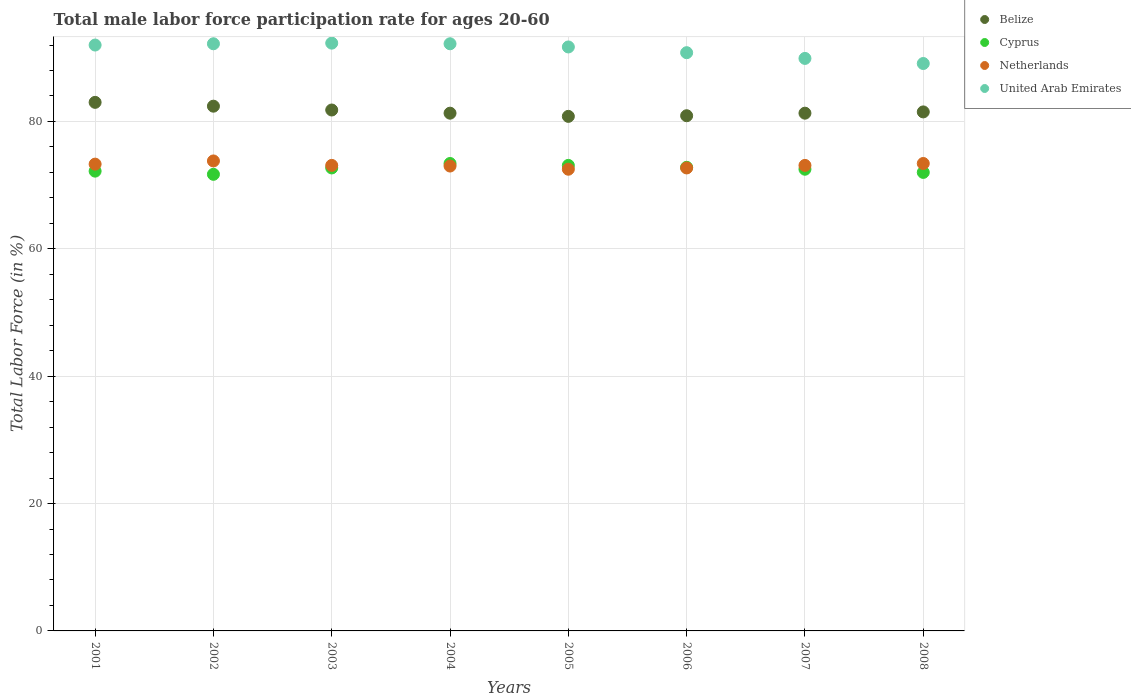How many different coloured dotlines are there?
Your response must be concise. 4. Across all years, what is the maximum male labor force participation rate in United Arab Emirates?
Your answer should be very brief. 92.3. Across all years, what is the minimum male labor force participation rate in Cyprus?
Offer a very short reply. 71.7. In which year was the male labor force participation rate in United Arab Emirates maximum?
Your response must be concise. 2003. In which year was the male labor force participation rate in Netherlands minimum?
Offer a terse response. 2005. What is the total male labor force participation rate in Netherlands in the graph?
Provide a short and direct response. 584.9. What is the difference between the male labor force participation rate in Belize in 2003 and that in 2005?
Keep it short and to the point. 1. What is the average male labor force participation rate in United Arab Emirates per year?
Provide a short and direct response. 91.27. In the year 2007, what is the difference between the male labor force participation rate in Netherlands and male labor force participation rate in Cyprus?
Ensure brevity in your answer.  0.6. What is the ratio of the male labor force participation rate in United Arab Emirates in 2005 to that in 2006?
Ensure brevity in your answer.  1.01. Is the male labor force participation rate in Belize in 2005 less than that in 2008?
Keep it short and to the point. Yes. Is the difference between the male labor force participation rate in Netherlands in 2006 and 2008 greater than the difference between the male labor force participation rate in Cyprus in 2006 and 2008?
Provide a succinct answer. No. What is the difference between the highest and the second highest male labor force participation rate in Netherlands?
Your answer should be very brief. 0.4. What is the difference between the highest and the lowest male labor force participation rate in United Arab Emirates?
Offer a very short reply. 3.2. In how many years, is the male labor force participation rate in Cyprus greater than the average male labor force participation rate in Cyprus taken over all years?
Keep it short and to the point. 4. Is it the case that in every year, the sum of the male labor force participation rate in Belize and male labor force participation rate in United Arab Emirates  is greater than the sum of male labor force participation rate in Cyprus and male labor force participation rate in Netherlands?
Make the answer very short. Yes. Does the male labor force participation rate in Netherlands monotonically increase over the years?
Offer a very short reply. No. Are the values on the major ticks of Y-axis written in scientific E-notation?
Offer a terse response. No. Does the graph contain any zero values?
Your answer should be very brief. No. Does the graph contain grids?
Your response must be concise. Yes. How many legend labels are there?
Your answer should be very brief. 4. What is the title of the graph?
Ensure brevity in your answer.  Total male labor force participation rate for ages 20-60. What is the label or title of the X-axis?
Your answer should be very brief. Years. What is the Total Labor Force (in %) in Belize in 2001?
Your answer should be very brief. 83. What is the Total Labor Force (in %) of Cyprus in 2001?
Give a very brief answer. 72.2. What is the Total Labor Force (in %) in Netherlands in 2001?
Offer a very short reply. 73.3. What is the Total Labor Force (in %) in United Arab Emirates in 2001?
Your answer should be compact. 92. What is the Total Labor Force (in %) in Belize in 2002?
Give a very brief answer. 82.4. What is the Total Labor Force (in %) of Cyprus in 2002?
Offer a terse response. 71.7. What is the Total Labor Force (in %) of Netherlands in 2002?
Your answer should be very brief. 73.8. What is the Total Labor Force (in %) of United Arab Emirates in 2002?
Offer a terse response. 92.2. What is the Total Labor Force (in %) of Belize in 2003?
Make the answer very short. 81.8. What is the Total Labor Force (in %) of Cyprus in 2003?
Offer a terse response. 72.7. What is the Total Labor Force (in %) in Netherlands in 2003?
Your response must be concise. 73.1. What is the Total Labor Force (in %) in United Arab Emirates in 2003?
Your answer should be compact. 92.3. What is the Total Labor Force (in %) in Belize in 2004?
Provide a succinct answer. 81.3. What is the Total Labor Force (in %) in Cyprus in 2004?
Your answer should be very brief. 73.4. What is the Total Labor Force (in %) in Netherlands in 2004?
Make the answer very short. 73. What is the Total Labor Force (in %) of United Arab Emirates in 2004?
Keep it short and to the point. 92.2. What is the Total Labor Force (in %) of Belize in 2005?
Your answer should be very brief. 80.8. What is the Total Labor Force (in %) in Cyprus in 2005?
Your response must be concise. 73.1. What is the Total Labor Force (in %) of Netherlands in 2005?
Offer a very short reply. 72.5. What is the Total Labor Force (in %) in United Arab Emirates in 2005?
Offer a terse response. 91.7. What is the Total Labor Force (in %) in Belize in 2006?
Offer a very short reply. 80.9. What is the Total Labor Force (in %) in Cyprus in 2006?
Your answer should be compact. 72.8. What is the Total Labor Force (in %) of Netherlands in 2006?
Your answer should be compact. 72.7. What is the Total Labor Force (in %) in United Arab Emirates in 2006?
Give a very brief answer. 90.8. What is the Total Labor Force (in %) in Belize in 2007?
Make the answer very short. 81.3. What is the Total Labor Force (in %) in Cyprus in 2007?
Ensure brevity in your answer.  72.5. What is the Total Labor Force (in %) of Netherlands in 2007?
Ensure brevity in your answer.  73.1. What is the Total Labor Force (in %) of United Arab Emirates in 2007?
Ensure brevity in your answer.  89.9. What is the Total Labor Force (in %) in Belize in 2008?
Your answer should be very brief. 81.5. What is the Total Labor Force (in %) in Netherlands in 2008?
Keep it short and to the point. 73.4. What is the Total Labor Force (in %) of United Arab Emirates in 2008?
Provide a short and direct response. 89.1. Across all years, what is the maximum Total Labor Force (in %) in Belize?
Your answer should be compact. 83. Across all years, what is the maximum Total Labor Force (in %) of Cyprus?
Keep it short and to the point. 73.4. Across all years, what is the maximum Total Labor Force (in %) of Netherlands?
Make the answer very short. 73.8. Across all years, what is the maximum Total Labor Force (in %) of United Arab Emirates?
Offer a terse response. 92.3. Across all years, what is the minimum Total Labor Force (in %) in Belize?
Your answer should be very brief. 80.8. Across all years, what is the minimum Total Labor Force (in %) of Cyprus?
Make the answer very short. 71.7. Across all years, what is the minimum Total Labor Force (in %) of Netherlands?
Your answer should be very brief. 72.5. Across all years, what is the minimum Total Labor Force (in %) of United Arab Emirates?
Your answer should be compact. 89.1. What is the total Total Labor Force (in %) in Belize in the graph?
Your response must be concise. 653. What is the total Total Labor Force (in %) of Cyprus in the graph?
Provide a succinct answer. 580.4. What is the total Total Labor Force (in %) of Netherlands in the graph?
Keep it short and to the point. 584.9. What is the total Total Labor Force (in %) of United Arab Emirates in the graph?
Keep it short and to the point. 730.2. What is the difference between the Total Labor Force (in %) in Belize in 2001 and that in 2002?
Ensure brevity in your answer.  0.6. What is the difference between the Total Labor Force (in %) in United Arab Emirates in 2001 and that in 2002?
Your answer should be very brief. -0.2. What is the difference between the Total Labor Force (in %) of Belize in 2001 and that in 2003?
Ensure brevity in your answer.  1.2. What is the difference between the Total Labor Force (in %) of Cyprus in 2001 and that in 2003?
Your answer should be very brief. -0.5. What is the difference between the Total Labor Force (in %) in Netherlands in 2001 and that in 2003?
Your answer should be very brief. 0.2. What is the difference between the Total Labor Force (in %) of Belize in 2001 and that in 2004?
Give a very brief answer. 1.7. What is the difference between the Total Labor Force (in %) in Netherlands in 2001 and that in 2004?
Ensure brevity in your answer.  0.3. What is the difference between the Total Labor Force (in %) in United Arab Emirates in 2001 and that in 2004?
Provide a succinct answer. -0.2. What is the difference between the Total Labor Force (in %) in Belize in 2001 and that in 2005?
Your answer should be compact. 2.2. What is the difference between the Total Labor Force (in %) of Netherlands in 2001 and that in 2005?
Provide a short and direct response. 0.8. What is the difference between the Total Labor Force (in %) of Belize in 2001 and that in 2006?
Provide a short and direct response. 2.1. What is the difference between the Total Labor Force (in %) in Cyprus in 2001 and that in 2006?
Your answer should be very brief. -0.6. What is the difference between the Total Labor Force (in %) of Netherlands in 2001 and that in 2006?
Give a very brief answer. 0.6. What is the difference between the Total Labor Force (in %) in United Arab Emirates in 2001 and that in 2006?
Provide a succinct answer. 1.2. What is the difference between the Total Labor Force (in %) in Belize in 2001 and that in 2007?
Provide a short and direct response. 1.7. What is the difference between the Total Labor Force (in %) of Cyprus in 2001 and that in 2007?
Your response must be concise. -0.3. What is the difference between the Total Labor Force (in %) of Netherlands in 2001 and that in 2007?
Offer a very short reply. 0.2. What is the difference between the Total Labor Force (in %) of United Arab Emirates in 2001 and that in 2007?
Provide a succinct answer. 2.1. What is the difference between the Total Labor Force (in %) of Belize in 2001 and that in 2008?
Give a very brief answer. 1.5. What is the difference between the Total Labor Force (in %) in Cyprus in 2001 and that in 2008?
Make the answer very short. 0.2. What is the difference between the Total Labor Force (in %) of United Arab Emirates in 2001 and that in 2008?
Your answer should be very brief. 2.9. What is the difference between the Total Labor Force (in %) in Cyprus in 2002 and that in 2003?
Give a very brief answer. -1. What is the difference between the Total Labor Force (in %) of Netherlands in 2002 and that in 2003?
Ensure brevity in your answer.  0.7. What is the difference between the Total Labor Force (in %) in United Arab Emirates in 2002 and that in 2003?
Your answer should be very brief. -0.1. What is the difference between the Total Labor Force (in %) in Belize in 2002 and that in 2004?
Your answer should be compact. 1.1. What is the difference between the Total Labor Force (in %) of Cyprus in 2002 and that in 2004?
Keep it short and to the point. -1.7. What is the difference between the Total Labor Force (in %) of Belize in 2002 and that in 2005?
Make the answer very short. 1.6. What is the difference between the Total Labor Force (in %) of Netherlands in 2002 and that in 2005?
Your answer should be very brief. 1.3. What is the difference between the Total Labor Force (in %) of United Arab Emirates in 2002 and that in 2005?
Offer a terse response. 0.5. What is the difference between the Total Labor Force (in %) of Cyprus in 2002 and that in 2006?
Your response must be concise. -1.1. What is the difference between the Total Labor Force (in %) in Belize in 2002 and that in 2007?
Keep it short and to the point. 1.1. What is the difference between the Total Labor Force (in %) in Belize in 2002 and that in 2008?
Keep it short and to the point. 0.9. What is the difference between the Total Labor Force (in %) of Netherlands in 2002 and that in 2008?
Offer a terse response. 0.4. What is the difference between the Total Labor Force (in %) in United Arab Emirates in 2002 and that in 2008?
Offer a terse response. 3.1. What is the difference between the Total Labor Force (in %) of Belize in 2003 and that in 2004?
Offer a terse response. 0.5. What is the difference between the Total Labor Force (in %) of Cyprus in 2003 and that in 2004?
Your answer should be very brief. -0.7. What is the difference between the Total Labor Force (in %) in Netherlands in 2003 and that in 2004?
Provide a succinct answer. 0.1. What is the difference between the Total Labor Force (in %) of Cyprus in 2003 and that in 2006?
Your answer should be compact. -0.1. What is the difference between the Total Labor Force (in %) in Netherlands in 2003 and that in 2006?
Offer a very short reply. 0.4. What is the difference between the Total Labor Force (in %) of Cyprus in 2003 and that in 2007?
Offer a terse response. 0.2. What is the difference between the Total Labor Force (in %) in Netherlands in 2003 and that in 2007?
Make the answer very short. 0. What is the difference between the Total Labor Force (in %) of Belize in 2003 and that in 2008?
Ensure brevity in your answer.  0.3. What is the difference between the Total Labor Force (in %) of Belize in 2004 and that in 2005?
Ensure brevity in your answer.  0.5. What is the difference between the Total Labor Force (in %) in Netherlands in 2004 and that in 2005?
Offer a terse response. 0.5. What is the difference between the Total Labor Force (in %) of United Arab Emirates in 2004 and that in 2005?
Your answer should be very brief. 0.5. What is the difference between the Total Labor Force (in %) in Belize in 2004 and that in 2006?
Provide a succinct answer. 0.4. What is the difference between the Total Labor Force (in %) in United Arab Emirates in 2004 and that in 2006?
Your answer should be compact. 1.4. What is the difference between the Total Labor Force (in %) of Cyprus in 2004 and that in 2007?
Give a very brief answer. 0.9. What is the difference between the Total Labor Force (in %) in United Arab Emirates in 2004 and that in 2007?
Offer a terse response. 2.3. What is the difference between the Total Labor Force (in %) of Netherlands in 2004 and that in 2008?
Your response must be concise. -0.4. What is the difference between the Total Labor Force (in %) in Cyprus in 2005 and that in 2007?
Offer a very short reply. 0.6. What is the difference between the Total Labor Force (in %) in Netherlands in 2005 and that in 2007?
Provide a short and direct response. -0.6. What is the difference between the Total Labor Force (in %) in Belize in 2005 and that in 2008?
Your answer should be very brief. -0.7. What is the difference between the Total Labor Force (in %) in Cyprus in 2005 and that in 2008?
Offer a very short reply. 1.1. What is the difference between the Total Labor Force (in %) in Netherlands in 2005 and that in 2008?
Your answer should be very brief. -0.9. What is the difference between the Total Labor Force (in %) in United Arab Emirates in 2005 and that in 2008?
Provide a short and direct response. 2.6. What is the difference between the Total Labor Force (in %) in Netherlands in 2006 and that in 2007?
Provide a succinct answer. -0.4. What is the difference between the Total Labor Force (in %) of Cyprus in 2006 and that in 2008?
Provide a short and direct response. 0.8. What is the difference between the Total Labor Force (in %) in Netherlands in 2006 and that in 2008?
Your answer should be compact. -0.7. What is the difference between the Total Labor Force (in %) in United Arab Emirates in 2007 and that in 2008?
Give a very brief answer. 0.8. What is the difference between the Total Labor Force (in %) in Belize in 2001 and the Total Labor Force (in %) in Netherlands in 2002?
Offer a very short reply. 9.2. What is the difference between the Total Labor Force (in %) of Belize in 2001 and the Total Labor Force (in %) of United Arab Emirates in 2002?
Your response must be concise. -9.2. What is the difference between the Total Labor Force (in %) in Cyprus in 2001 and the Total Labor Force (in %) in United Arab Emirates in 2002?
Offer a very short reply. -20. What is the difference between the Total Labor Force (in %) of Netherlands in 2001 and the Total Labor Force (in %) of United Arab Emirates in 2002?
Offer a terse response. -18.9. What is the difference between the Total Labor Force (in %) in Belize in 2001 and the Total Labor Force (in %) in Cyprus in 2003?
Your answer should be very brief. 10.3. What is the difference between the Total Labor Force (in %) of Belize in 2001 and the Total Labor Force (in %) of Netherlands in 2003?
Keep it short and to the point. 9.9. What is the difference between the Total Labor Force (in %) in Belize in 2001 and the Total Labor Force (in %) in United Arab Emirates in 2003?
Make the answer very short. -9.3. What is the difference between the Total Labor Force (in %) of Cyprus in 2001 and the Total Labor Force (in %) of United Arab Emirates in 2003?
Offer a very short reply. -20.1. What is the difference between the Total Labor Force (in %) in Belize in 2001 and the Total Labor Force (in %) in Netherlands in 2004?
Ensure brevity in your answer.  10. What is the difference between the Total Labor Force (in %) of Cyprus in 2001 and the Total Labor Force (in %) of United Arab Emirates in 2004?
Offer a terse response. -20. What is the difference between the Total Labor Force (in %) of Netherlands in 2001 and the Total Labor Force (in %) of United Arab Emirates in 2004?
Your answer should be very brief. -18.9. What is the difference between the Total Labor Force (in %) in Belize in 2001 and the Total Labor Force (in %) in Cyprus in 2005?
Make the answer very short. 9.9. What is the difference between the Total Labor Force (in %) in Belize in 2001 and the Total Labor Force (in %) in Netherlands in 2005?
Give a very brief answer. 10.5. What is the difference between the Total Labor Force (in %) in Cyprus in 2001 and the Total Labor Force (in %) in United Arab Emirates in 2005?
Offer a terse response. -19.5. What is the difference between the Total Labor Force (in %) in Netherlands in 2001 and the Total Labor Force (in %) in United Arab Emirates in 2005?
Give a very brief answer. -18.4. What is the difference between the Total Labor Force (in %) in Cyprus in 2001 and the Total Labor Force (in %) in Netherlands in 2006?
Offer a terse response. -0.5. What is the difference between the Total Labor Force (in %) in Cyprus in 2001 and the Total Labor Force (in %) in United Arab Emirates in 2006?
Your answer should be compact. -18.6. What is the difference between the Total Labor Force (in %) in Netherlands in 2001 and the Total Labor Force (in %) in United Arab Emirates in 2006?
Your response must be concise. -17.5. What is the difference between the Total Labor Force (in %) in Belize in 2001 and the Total Labor Force (in %) in United Arab Emirates in 2007?
Your response must be concise. -6.9. What is the difference between the Total Labor Force (in %) in Cyprus in 2001 and the Total Labor Force (in %) in United Arab Emirates in 2007?
Your answer should be compact. -17.7. What is the difference between the Total Labor Force (in %) in Netherlands in 2001 and the Total Labor Force (in %) in United Arab Emirates in 2007?
Give a very brief answer. -16.6. What is the difference between the Total Labor Force (in %) of Belize in 2001 and the Total Labor Force (in %) of Netherlands in 2008?
Provide a short and direct response. 9.6. What is the difference between the Total Labor Force (in %) of Belize in 2001 and the Total Labor Force (in %) of United Arab Emirates in 2008?
Ensure brevity in your answer.  -6.1. What is the difference between the Total Labor Force (in %) in Cyprus in 2001 and the Total Labor Force (in %) in Netherlands in 2008?
Your answer should be compact. -1.2. What is the difference between the Total Labor Force (in %) of Cyprus in 2001 and the Total Labor Force (in %) of United Arab Emirates in 2008?
Give a very brief answer. -16.9. What is the difference between the Total Labor Force (in %) of Netherlands in 2001 and the Total Labor Force (in %) of United Arab Emirates in 2008?
Provide a succinct answer. -15.8. What is the difference between the Total Labor Force (in %) in Belize in 2002 and the Total Labor Force (in %) in Netherlands in 2003?
Your response must be concise. 9.3. What is the difference between the Total Labor Force (in %) in Cyprus in 2002 and the Total Labor Force (in %) in United Arab Emirates in 2003?
Ensure brevity in your answer.  -20.6. What is the difference between the Total Labor Force (in %) in Netherlands in 2002 and the Total Labor Force (in %) in United Arab Emirates in 2003?
Keep it short and to the point. -18.5. What is the difference between the Total Labor Force (in %) of Cyprus in 2002 and the Total Labor Force (in %) of United Arab Emirates in 2004?
Offer a terse response. -20.5. What is the difference between the Total Labor Force (in %) in Netherlands in 2002 and the Total Labor Force (in %) in United Arab Emirates in 2004?
Offer a terse response. -18.4. What is the difference between the Total Labor Force (in %) of Belize in 2002 and the Total Labor Force (in %) of Cyprus in 2005?
Ensure brevity in your answer.  9.3. What is the difference between the Total Labor Force (in %) of Belize in 2002 and the Total Labor Force (in %) of Netherlands in 2005?
Offer a very short reply. 9.9. What is the difference between the Total Labor Force (in %) of Belize in 2002 and the Total Labor Force (in %) of United Arab Emirates in 2005?
Keep it short and to the point. -9.3. What is the difference between the Total Labor Force (in %) of Cyprus in 2002 and the Total Labor Force (in %) of Netherlands in 2005?
Your answer should be very brief. -0.8. What is the difference between the Total Labor Force (in %) in Netherlands in 2002 and the Total Labor Force (in %) in United Arab Emirates in 2005?
Offer a terse response. -17.9. What is the difference between the Total Labor Force (in %) in Belize in 2002 and the Total Labor Force (in %) in Netherlands in 2006?
Offer a terse response. 9.7. What is the difference between the Total Labor Force (in %) in Belize in 2002 and the Total Labor Force (in %) in United Arab Emirates in 2006?
Your answer should be very brief. -8.4. What is the difference between the Total Labor Force (in %) in Cyprus in 2002 and the Total Labor Force (in %) in Netherlands in 2006?
Your response must be concise. -1. What is the difference between the Total Labor Force (in %) in Cyprus in 2002 and the Total Labor Force (in %) in United Arab Emirates in 2006?
Make the answer very short. -19.1. What is the difference between the Total Labor Force (in %) in Cyprus in 2002 and the Total Labor Force (in %) in United Arab Emirates in 2007?
Your answer should be very brief. -18.2. What is the difference between the Total Labor Force (in %) of Netherlands in 2002 and the Total Labor Force (in %) of United Arab Emirates in 2007?
Give a very brief answer. -16.1. What is the difference between the Total Labor Force (in %) of Belize in 2002 and the Total Labor Force (in %) of Cyprus in 2008?
Ensure brevity in your answer.  10.4. What is the difference between the Total Labor Force (in %) in Belize in 2002 and the Total Labor Force (in %) in Netherlands in 2008?
Your response must be concise. 9. What is the difference between the Total Labor Force (in %) in Belize in 2002 and the Total Labor Force (in %) in United Arab Emirates in 2008?
Keep it short and to the point. -6.7. What is the difference between the Total Labor Force (in %) of Cyprus in 2002 and the Total Labor Force (in %) of United Arab Emirates in 2008?
Your answer should be compact. -17.4. What is the difference between the Total Labor Force (in %) in Netherlands in 2002 and the Total Labor Force (in %) in United Arab Emirates in 2008?
Your answer should be very brief. -15.3. What is the difference between the Total Labor Force (in %) of Belize in 2003 and the Total Labor Force (in %) of Cyprus in 2004?
Offer a very short reply. 8.4. What is the difference between the Total Labor Force (in %) of Cyprus in 2003 and the Total Labor Force (in %) of Netherlands in 2004?
Your answer should be compact. -0.3. What is the difference between the Total Labor Force (in %) of Cyprus in 2003 and the Total Labor Force (in %) of United Arab Emirates in 2004?
Give a very brief answer. -19.5. What is the difference between the Total Labor Force (in %) in Netherlands in 2003 and the Total Labor Force (in %) in United Arab Emirates in 2004?
Your response must be concise. -19.1. What is the difference between the Total Labor Force (in %) of Belize in 2003 and the Total Labor Force (in %) of United Arab Emirates in 2005?
Ensure brevity in your answer.  -9.9. What is the difference between the Total Labor Force (in %) in Netherlands in 2003 and the Total Labor Force (in %) in United Arab Emirates in 2005?
Offer a very short reply. -18.6. What is the difference between the Total Labor Force (in %) of Belize in 2003 and the Total Labor Force (in %) of Cyprus in 2006?
Your answer should be very brief. 9. What is the difference between the Total Labor Force (in %) of Cyprus in 2003 and the Total Labor Force (in %) of Netherlands in 2006?
Make the answer very short. 0. What is the difference between the Total Labor Force (in %) in Cyprus in 2003 and the Total Labor Force (in %) in United Arab Emirates in 2006?
Your answer should be very brief. -18.1. What is the difference between the Total Labor Force (in %) of Netherlands in 2003 and the Total Labor Force (in %) of United Arab Emirates in 2006?
Your response must be concise. -17.7. What is the difference between the Total Labor Force (in %) of Belize in 2003 and the Total Labor Force (in %) of Netherlands in 2007?
Keep it short and to the point. 8.7. What is the difference between the Total Labor Force (in %) in Belize in 2003 and the Total Labor Force (in %) in United Arab Emirates in 2007?
Your response must be concise. -8.1. What is the difference between the Total Labor Force (in %) of Cyprus in 2003 and the Total Labor Force (in %) of United Arab Emirates in 2007?
Keep it short and to the point. -17.2. What is the difference between the Total Labor Force (in %) of Netherlands in 2003 and the Total Labor Force (in %) of United Arab Emirates in 2007?
Offer a terse response. -16.8. What is the difference between the Total Labor Force (in %) in Belize in 2003 and the Total Labor Force (in %) in Cyprus in 2008?
Make the answer very short. 9.8. What is the difference between the Total Labor Force (in %) of Belize in 2003 and the Total Labor Force (in %) of Netherlands in 2008?
Ensure brevity in your answer.  8.4. What is the difference between the Total Labor Force (in %) of Cyprus in 2003 and the Total Labor Force (in %) of Netherlands in 2008?
Your response must be concise. -0.7. What is the difference between the Total Labor Force (in %) in Cyprus in 2003 and the Total Labor Force (in %) in United Arab Emirates in 2008?
Provide a short and direct response. -16.4. What is the difference between the Total Labor Force (in %) of Netherlands in 2003 and the Total Labor Force (in %) of United Arab Emirates in 2008?
Give a very brief answer. -16. What is the difference between the Total Labor Force (in %) in Belize in 2004 and the Total Labor Force (in %) in United Arab Emirates in 2005?
Offer a very short reply. -10.4. What is the difference between the Total Labor Force (in %) in Cyprus in 2004 and the Total Labor Force (in %) in Netherlands in 2005?
Keep it short and to the point. 0.9. What is the difference between the Total Labor Force (in %) of Cyprus in 2004 and the Total Labor Force (in %) of United Arab Emirates in 2005?
Offer a very short reply. -18.3. What is the difference between the Total Labor Force (in %) of Netherlands in 2004 and the Total Labor Force (in %) of United Arab Emirates in 2005?
Keep it short and to the point. -18.7. What is the difference between the Total Labor Force (in %) of Belize in 2004 and the Total Labor Force (in %) of United Arab Emirates in 2006?
Make the answer very short. -9.5. What is the difference between the Total Labor Force (in %) of Cyprus in 2004 and the Total Labor Force (in %) of United Arab Emirates in 2006?
Give a very brief answer. -17.4. What is the difference between the Total Labor Force (in %) of Netherlands in 2004 and the Total Labor Force (in %) of United Arab Emirates in 2006?
Your response must be concise. -17.8. What is the difference between the Total Labor Force (in %) of Belize in 2004 and the Total Labor Force (in %) of Cyprus in 2007?
Keep it short and to the point. 8.8. What is the difference between the Total Labor Force (in %) in Belize in 2004 and the Total Labor Force (in %) in Netherlands in 2007?
Make the answer very short. 8.2. What is the difference between the Total Labor Force (in %) in Belize in 2004 and the Total Labor Force (in %) in United Arab Emirates in 2007?
Keep it short and to the point. -8.6. What is the difference between the Total Labor Force (in %) of Cyprus in 2004 and the Total Labor Force (in %) of Netherlands in 2007?
Give a very brief answer. 0.3. What is the difference between the Total Labor Force (in %) of Cyprus in 2004 and the Total Labor Force (in %) of United Arab Emirates in 2007?
Your response must be concise. -16.5. What is the difference between the Total Labor Force (in %) of Netherlands in 2004 and the Total Labor Force (in %) of United Arab Emirates in 2007?
Provide a short and direct response. -16.9. What is the difference between the Total Labor Force (in %) of Belize in 2004 and the Total Labor Force (in %) of Cyprus in 2008?
Ensure brevity in your answer.  9.3. What is the difference between the Total Labor Force (in %) in Belize in 2004 and the Total Labor Force (in %) in Netherlands in 2008?
Ensure brevity in your answer.  7.9. What is the difference between the Total Labor Force (in %) of Belize in 2004 and the Total Labor Force (in %) of United Arab Emirates in 2008?
Your response must be concise. -7.8. What is the difference between the Total Labor Force (in %) of Cyprus in 2004 and the Total Labor Force (in %) of Netherlands in 2008?
Give a very brief answer. 0. What is the difference between the Total Labor Force (in %) of Cyprus in 2004 and the Total Labor Force (in %) of United Arab Emirates in 2008?
Your answer should be very brief. -15.7. What is the difference between the Total Labor Force (in %) in Netherlands in 2004 and the Total Labor Force (in %) in United Arab Emirates in 2008?
Ensure brevity in your answer.  -16.1. What is the difference between the Total Labor Force (in %) in Belize in 2005 and the Total Labor Force (in %) in Cyprus in 2006?
Your answer should be very brief. 8. What is the difference between the Total Labor Force (in %) in Belize in 2005 and the Total Labor Force (in %) in United Arab Emirates in 2006?
Offer a terse response. -10. What is the difference between the Total Labor Force (in %) of Cyprus in 2005 and the Total Labor Force (in %) of United Arab Emirates in 2006?
Ensure brevity in your answer.  -17.7. What is the difference between the Total Labor Force (in %) of Netherlands in 2005 and the Total Labor Force (in %) of United Arab Emirates in 2006?
Give a very brief answer. -18.3. What is the difference between the Total Labor Force (in %) of Belize in 2005 and the Total Labor Force (in %) of Cyprus in 2007?
Keep it short and to the point. 8.3. What is the difference between the Total Labor Force (in %) of Cyprus in 2005 and the Total Labor Force (in %) of Netherlands in 2007?
Keep it short and to the point. 0. What is the difference between the Total Labor Force (in %) in Cyprus in 2005 and the Total Labor Force (in %) in United Arab Emirates in 2007?
Offer a very short reply. -16.8. What is the difference between the Total Labor Force (in %) in Netherlands in 2005 and the Total Labor Force (in %) in United Arab Emirates in 2007?
Your answer should be very brief. -17.4. What is the difference between the Total Labor Force (in %) of Belize in 2005 and the Total Labor Force (in %) of Netherlands in 2008?
Make the answer very short. 7.4. What is the difference between the Total Labor Force (in %) in Belize in 2005 and the Total Labor Force (in %) in United Arab Emirates in 2008?
Make the answer very short. -8.3. What is the difference between the Total Labor Force (in %) in Netherlands in 2005 and the Total Labor Force (in %) in United Arab Emirates in 2008?
Your answer should be very brief. -16.6. What is the difference between the Total Labor Force (in %) in Cyprus in 2006 and the Total Labor Force (in %) in Netherlands in 2007?
Ensure brevity in your answer.  -0.3. What is the difference between the Total Labor Force (in %) of Cyprus in 2006 and the Total Labor Force (in %) of United Arab Emirates in 2007?
Give a very brief answer. -17.1. What is the difference between the Total Labor Force (in %) in Netherlands in 2006 and the Total Labor Force (in %) in United Arab Emirates in 2007?
Offer a terse response. -17.2. What is the difference between the Total Labor Force (in %) in Belize in 2006 and the Total Labor Force (in %) in Cyprus in 2008?
Keep it short and to the point. 8.9. What is the difference between the Total Labor Force (in %) in Belize in 2006 and the Total Labor Force (in %) in Netherlands in 2008?
Ensure brevity in your answer.  7.5. What is the difference between the Total Labor Force (in %) in Cyprus in 2006 and the Total Labor Force (in %) in United Arab Emirates in 2008?
Provide a succinct answer. -16.3. What is the difference between the Total Labor Force (in %) of Netherlands in 2006 and the Total Labor Force (in %) of United Arab Emirates in 2008?
Give a very brief answer. -16.4. What is the difference between the Total Labor Force (in %) of Belize in 2007 and the Total Labor Force (in %) of Cyprus in 2008?
Offer a terse response. 9.3. What is the difference between the Total Labor Force (in %) in Belize in 2007 and the Total Labor Force (in %) in Netherlands in 2008?
Your answer should be compact. 7.9. What is the difference between the Total Labor Force (in %) of Cyprus in 2007 and the Total Labor Force (in %) of United Arab Emirates in 2008?
Ensure brevity in your answer.  -16.6. What is the difference between the Total Labor Force (in %) of Netherlands in 2007 and the Total Labor Force (in %) of United Arab Emirates in 2008?
Give a very brief answer. -16. What is the average Total Labor Force (in %) of Belize per year?
Your answer should be very brief. 81.62. What is the average Total Labor Force (in %) in Cyprus per year?
Provide a short and direct response. 72.55. What is the average Total Labor Force (in %) of Netherlands per year?
Keep it short and to the point. 73.11. What is the average Total Labor Force (in %) of United Arab Emirates per year?
Make the answer very short. 91.28. In the year 2001, what is the difference between the Total Labor Force (in %) in Belize and Total Labor Force (in %) in Netherlands?
Give a very brief answer. 9.7. In the year 2001, what is the difference between the Total Labor Force (in %) in Cyprus and Total Labor Force (in %) in United Arab Emirates?
Give a very brief answer. -19.8. In the year 2001, what is the difference between the Total Labor Force (in %) of Netherlands and Total Labor Force (in %) of United Arab Emirates?
Ensure brevity in your answer.  -18.7. In the year 2002, what is the difference between the Total Labor Force (in %) of Belize and Total Labor Force (in %) of Netherlands?
Your response must be concise. 8.6. In the year 2002, what is the difference between the Total Labor Force (in %) in Cyprus and Total Labor Force (in %) in Netherlands?
Keep it short and to the point. -2.1. In the year 2002, what is the difference between the Total Labor Force (in %) of Cyprus and Total Labor Force (in %) of United Arab Emirates?
Ensure brevity in your answer.  -20.5. In the year 2002, what is the difference between the Total Labor Force (in %) in Netherlands and Total Labor Force (in %) in United Arab Emirates?
Provide a succinct answer. -18.4. In the year 2003, what is the difference between the Total Labor Force (in %) in Belize and Total Labor Force (in %) in Netherlands?
Provide a short and direct response. 8.7. In the year 2003, what is the difference between the Total Labor Force (in %) in Cyprus and Total Labor Force (in %) in United Arab Emirates?
Make the answer very short. -19.6. In the year 2003, what is the difference between the Total Labor Force (in %) of Netherlands and Total Labor Force (in %) of United Arab Emirates?
Offer a terse response. -19.2. In the year 2004, what is the difference between the Total Labor Force (in %) in Belize and Total Labor Force (in %) in Netherlands?
Offer a terse response. 8.3. In the year 2004, what is the difference between the Total Labor Force (in %) of Belize and Total Labor Force (in %) of United Arab Emirates?
Your answer should be compact. -10.9. In the year 2004, what is the difference between the Total Labor Force (in %) of Cyprus and Total Labor Force (in %) of United Arab Emirates?
Keep it short and to the point. -18.8. In the year 2004, what is the difference between the Total Labor Force (in %) in Netherlands and Total Labor Force (in %) in United Arab Emirates?
Your answer should be compact. -19.2. In the year 2005, what is the difference between the Total Labor Force (in %) of Belize and Total Labor Force (in %) of Cyprus?
Offer a terse response. 7.7. In the year 2005, what is the difference between the Total Labor Force (in %) in Cyprus and Total Labor Force (in %) in Netherlands?
Your answer should be compact. 0.6. In the year 2005, what is the difference between the Total Labor Force (in %) of Cyprus and Total Labor Force (in %) of United Arab Emirates?
Your answer should be very brief. -18.6. In the year 2005, what is the difference between the Total Labor Force (in %) in Netherlands and Total Labor Force (in %) in United Arab Emirates?
Keep it short and to the point. -19.2. In the year 2006, what is the difference between the Total Labor Force (in %) in Belize and Total Labor Force (in %) in Netherlands?
Offer a terse response. 8.2. In the year 2006, what is the difference between the Total Labor Force (in %) in Netherlands and Total Labor Force (in %) in United Arab Emirates?
Your answer should be very brief. -18.1. In the year 2007, what is the difference between the Total Labor Force (in %) in Belize and Total Labor Force (in %) in Netherlands?
Your answer should be compact. 8.2. In the year 2007, what is the difference between the Total Labor Force (in %) in Belize and Total Labor Force (in %) in United Arab Emirates?
Keep it short and to the point. -8.6. In the year 2007, what is the difference between the Total Labor Force (in %) of Cyprus and Total Labor Force (in %) of United Arab Emirates?
Your answer should be very brief. -17.4. In the year 2007, what is the difference between the Total Labor Force (in %) of Netherlands and Total Labor Force (in %) of United Arab Emirates?
Provide a short and direct response. -16.8. In the year 2008, what is the difference between the Total Labor Force (in %) in Belize and Total Labor Force (in %) in Cyprus?
Give a very brief answer. 9.5. In the year 2008, what is the difference between the Total Labor Force (in %) in Belize and Total Labor Force (in %) in Netherlands?
Offer a terse response. 8.1. In the year 2008, what is the difference between the Total Labor Force (in %) of Belize and Total Labor Force (in %) of United Arab Emirates?
Offer a terse response. -7.6. In the year 2008, what is the difference between the Total Labor Force (in %) of Cyprus and Total Labor Force (in %) of United Arab Emirates?
Provide a short and direct response. -17.1. In the year 2008, what is the difference between the Total Labor Force (in %) in Netherlands and Total Labor Force (in %) in United Arab Emirates?
Offer a very short reply. -15.7. What is the ratio of the Total Labor Force (in %) of Belize in 2001 to that in 2002?
Offer a very short reply. 1.01. What is the ratio of the Total Labor Force (in %) in Netherlands in 2001 to that in 2002?
Your answer should be very brief. 0.99. What is the ratio of the Total Labor Force (in %) of Belize in 2001 to that in 2003?
Ensure brevity in your answer.  1.01. What is the ratio of the Total Labor Force (in %) in Netherlands in 2001 to that in 2003?
Provide a short and direct response. 1. What is the ratio of the Total Labor Force (in %) in Belize in 2001 to that in 2004?
Provide a short and direct response. 1.02. What is the ratio of the Total Labor Force (in %) of Cyprus in 2001 to that in 2004?
Your response must be concise. 0.98. What is the ratio of the Total Labor Force (in %) in Belize in 2001 to that in 2005?
Your answer should be compact. 1.03. What is the ratio of the Total Labor Force (in %) in Cyprus in 2001 to that in 2005?
Make the answer very short. 0.99. What is the ratio of the Total Labor Force (in %) of United Arab Emirates in 2001 to that in 2005?
Offer a terse response. 1. What is the ratio of the Total Labor Force (in %) in Belize in 2001 to that in 2006?
Offer a very short reply. 1.03. What is the ratio of the Total Labor Force (in %) in Cyprus in 2001 to that in 2006?
Give a very brief answer. 0.99. What is the ratio of the Total Labor Force (in %) in Netherlands in 2001 to that in 2006?
Your response must be concise. 1.01. What is the ratio of the Total Labor Force (in %) in United Arab Emirates in 2001 to that in 2006?
Your answer should be compact. 1.01. What is the ratio of the Total Labor Force (in %) in Belize in 2001 to that in 2007?
Provide a succinct answer. 1.02. What is the ratio of the Total Labor Force (in %) in United Arab Emirates in 2001 to that in 2007?
Provide a short and direct response. 1.02. What is the ratio of the Total Labor Force (in %) in Belize in 2001 to that in 2008?
Keep it short and to the point. 1.02. What is the ratio of the Total Labor Force (in %) of United Arab Emirates in 2001 to that in 2008?
Ensure brevity in your answer.  1.03. What is the ratio of the Total Labor Force (in %) in Belize in 2002 to that in 2003?
Offer a very short reply. 1.01. What is the ratio of the Total Labor Force (in %) in Cyprus in 2002 to that in 2003?
Ensure brevity in your answer.  0.99. What is the ratio of the Total Labor Force (in %) of Netherlands in 2002 to that in 2003?
Provide a short and direct response. 1.01. What is the ratio of the Total Labor Force (in %) of United Arab Emirates in 2002 to that in 2003?
Ensure brevity in your answer.  1. What is the ratio of the Total Labor Force (in %) of Belize in 2002 to that in 2004?
Your response must be concise. 1.01. What is the ratio of the Total Labor Force (in %) of Cyprus in 2002 to that in 2004?
Offer a terse response. 0.98. What is the ratio of the Total Labor Force (in %) in Netherlands in 2002 to that in 2004?
Your response must be concise. 1.01. What is the ratio of the Total Labor Force (in %) in Belize in 2002 to that in 2005?
Your answer should be very brief. 1.02. What is the ratio of the Total Labor Force (in %) in Cyprus in 2002 to that in 2005?
Your answer should be compact. 0.98. What is the ratio of the Total Labor Force (in %) of Netherlands in 2002 to that in 2005?
Your answer should be compact. 1.02. What is the ratio of the Total Labor Force (in %) of United Arab Emirates in 2002 to that in 2005?
Your answer should be very brief. 1.01. What is the ratio of the Total Labor Force (in %) in Belize in 2002 to that in 2006?
Ensure brevity in your answer.  1.02. What is the ratio of the Total Labor Force (in %) in Cyprus in 2002 to that in 2006?
Offer a very short reply. 0.98. What is the ratio of the Total Labor Force (in %) of Netherlands in 2002 to that in 2006?
Give a very brief answer. 1.02. What is the ratio of the Total Labor Force (in %) in United Arab Emirates in 2002 to that in 2006?
Your response must be concise. 1.02. What is the ratio of the Total Labor Force (in %) in Belize in 2002 to that in 2007?
Give a very brief answer. 1.01. What is the ratio of the Total Labor Force (in %) of Netherlands in 2002 to that in 2007?
Offer a terse response. 1.01. What is the ratio of the Total Labor Force (in %) in United Arab Emirates in 2002 to that in 2007?
Your answer should be very brief. 1.03. What is the ratio of the Total Labor Force (in %) of Belize in 2002 to that in 2008?
Your response must be concise. 1.01. What is the ratio of the Total Labor Force (in %) of Netherlands in 2002 to that in 2008?
Your answer should be compact. 1.01. What is the ratio of the Total Labor Force (in %) in United Arab Emirates in 2002 to that in 2008?
Give a very brief answer. 1.03. What is the ratio of the Total Labor Force (in %) of Belize in 2003 to that in 2004?
Provide a short and direct response. 1.01. What is the ratio of the Total Labor Force (in %) of Cyprus in 2003 to that in 2004?
Give a very brief answer. 0.99. What is the ratio of the Total Labor Force (in %) in United Arab Emirates in 2003 to that in 2004?
Make the answer very short. 1. What is the ratio of the Total Labor Force (in %) of Belize in 2003 to that in 2005?
Offer a very short reply. 1.01. What is the ratio of the Total Labor Force (in %) of Cyprus in 2003 to that in 2005?
Your response must be concise. 0.99. What is the ratio of the Total Labor Force (in %) of Netherlands in 2003 to that in 2005?
Offer a very short reply. 1.01. What is the ratio of the Total Labor Force (in %) of Belize in 2003 to that in 2006?
Keep it short and to the point. 1.01. What is the ratio of the Total Labor Force (in %) in Cyprus in 2003 to that in 2006?
Give a very brief answer. 1. What is the ratio of the Total Labor Force (in %) in United Arab Emirates in 2003 to that in 2006?
Provide a short and direct response. 1.02. What is the ratio of the Total Labor Force (in %) of Cyprus in 2003 to that in 2007?
Give a very brief answer. 1. What is the ratio of the Total Labor Force (in %) of United Arab Emirates in 2003 to that in 2007?
Offer a very short reply. 1.03. What is the ratio of the Total Labor Force (in %) of Cyprus in 2003 to that in 2008?
Provide a short and direct response. 1.01. What is the ratio of the Total Labor Force (in %) of Netherlands in 2003 to that in 2008?
Offer a very short reply. 1. What is the ratio of the Total Labor Force (in %) of United Arab Emirates in 2003 to that in 2008?
Provide a succinct answer. 1.04. What is the ratio of the Total Labor Force (in %) in United Arab Emirates in 2004 to that in 2005?
Provide a succinct answer. 1.01. What is the ratio of the Total Labor Force (in %) in Belize in 2004 to that in 2006?
Your answer should be compact. 1. What is the ratio of the Total Labor Force (in %) in Cyprus in 2004 to that in 2006?
Give a very brief answer. 1.01. What is the ratio of the Total Labor Force (in %) of Netherlands in 2004 to that in 2006?
Give a very brief answer. 1. What is the ratio of the Total Labor Force (in %) of United Arab Emirates in 2004 to that in 2006?
Offer a terse response. 1.02. What is the ratio of the Total Labor Force (in %) of Cyprus in 2004 to that in 2007?
Keep it short and to the point. 1.01. What is the ratio of the Total Labor Force (in %) of United Arab Emirates in 2004 to that in 2007?
Provide a succinct answer. 1.03. What is the ratio of the Total Labor Force (in %) in Belize in 2004 to that in 2008?
Keep it short and to the point. 1. What is the ratio of the Total Labor Force (in %) in Cyprus in 2004 to that in 2008?
Offer a very short reply. 1.02. What is the ratio of the Total Labor Force (in %) in Netherlands in 2004 to that in 2008?
Provide a short and direct response. 0.99. What is the ratio of the Total Labor Force (in %) of United Arab Emirates in 2004 to that in 2008?
Provide a succinct answer. 1.03. What is the ratio of the Total Labor Force (in %) of Belize in 2005 to that in 2006?
Provide a short and direct response. 1. What is the ratio of the Total Labor Force (in %) of Netherlands in 2005 to that in 2006?
Ensure brevity in your answer.  1. What is the ratio of the Total Labor Force (in %) in United Arab Emirates in 2005 to that in 2006?
Keep it short and to the point. 1.01. What is the ratio of the Total Labor Force (in %) in Belize in 2005 to that in 2007?
Offer a terse response. 0.99. What is the ratio of the Total Labor Force (in %) of Cyprus in 2005 to that in 2007?
Provide a short and direct response. 1.01. What is the ratio of the Total Labor Force (in %) in United Arab Emirates in 2005 to that in 2007?
Give a very brief answer. 1.02. What is the ratio of the Total Labor Force (in %) of Cyprus in 2005 to that in 2008?
Your response must be concise. 1.02. What is the ratio of the Total Labor Force (in %) in Netherlands in 2005 to that in 2008?
Your answer should be very brief. 0.99. What is the ratio of the Total Labor Force (in %) of United Arab Emirates in 2005 to that in 2008?
Ensure brevity in your answer.  1.03. What is the ratio of the Total Labor Force (in %) in Belize in 2006 to that in 2007?
Offer a terse response. 1. What is the ratio of the Total Labor Force (in %) in Cyprus in 2006 to that in 2007?
Make the answer very short. 1. What is the ratio of the Total Labor Force (in %) of United Arab Emirates in 2006 to that in 2007?
Provide a short and direct response. 1.01. What is the ratio of the Total Labor Force (in %) in Belize in 2006 to that in 2008?
Offer a terse response. 0.99. What is the ratio of the Total Labor Force (in %) of Cyprus in 2006 to that in 2008?
Ensure brevity in your answer.  1.01. What is the ratio of the Total Labor Force (in %) of United Arab Emirates in 2006 to that in 2008?
Offer a terse response. 1.02. What is the ratio of the Total Labor Force (in %) of United Arab Emirates in 2007 to that in 2008?
Your answer should be very brief. 1.01. What is the difference between the highest and the second highest Total Labor Force (in %) of Belize?
Offer a terse response. 0.6. What is the difference between the highest and the second highest Total Labor Force (in %) in Netherlands?
Offer a terse response. 0.4. What is the difference between the highest and the second highest Total Labor Force (in %) in United Arab Emirates?
Provide a succinct answer. 0.1. What is the difference between the highest and the lowest Total Labor Force (in %) in Belize?
Keep it short and to the point. 2.2. What is the difference between the highest and the lowest Total Labor Force (in %) in Cyprus?
Give a very brief answer. 1.7. What is the difference between the highest and the lowest Total Labor Force (in %) of Netherlands?
Your answer should be very brief. 1.3. 